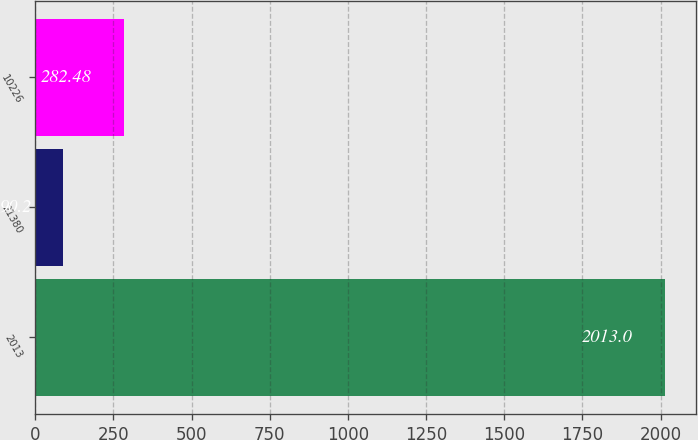<chart> <loc_0><loc_0><loc_500><loc_500><bar_chart><fcel>2013<fcel>21380<fcel>10226<nl><fcel>2013<fcel>90.2<fcel>282.48<nl></chart> 